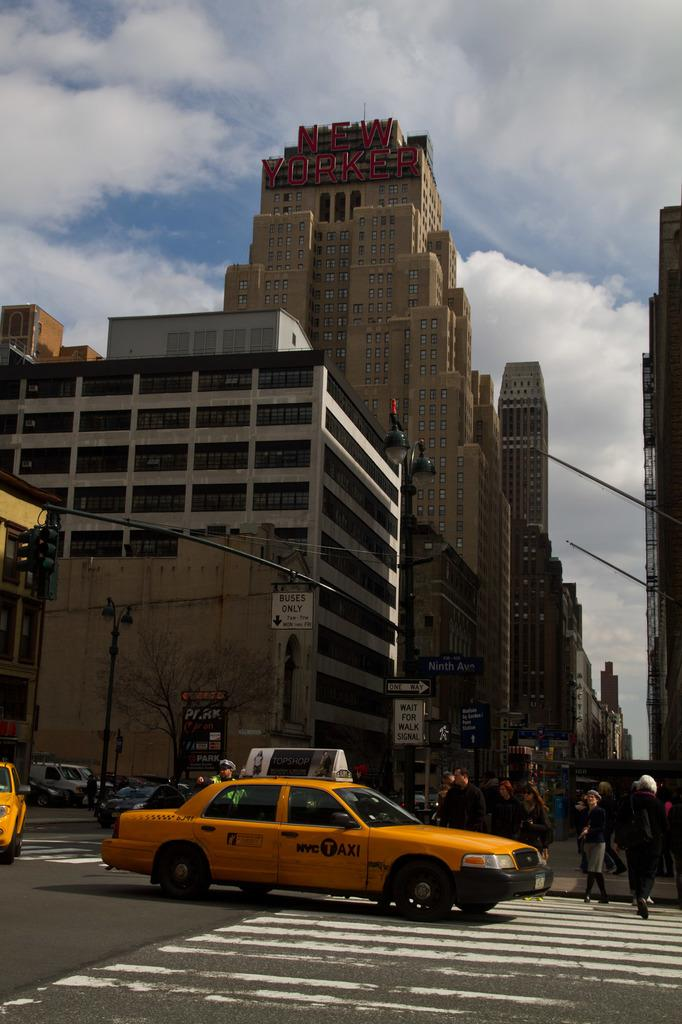<image>
Write a terse but informative summary of the picture. In a busy city scene, the New Yorker building towers over street traffic going one way. 